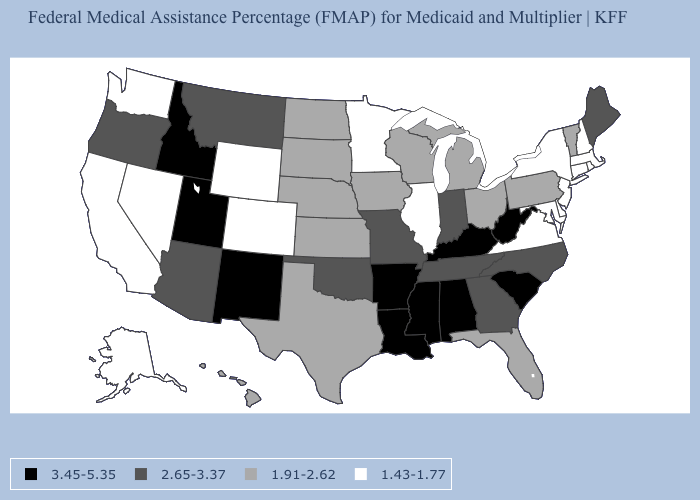Name the states that have a value in the range 2.65-3.37?
Answer briefly. Arizona, Georgia, Indiana, Maine, Missouri, Montana, North Carolina, Oklahoma, Oregon, Tennessee. What is the value of New Jersey?
Answer briefly. 1.43-1.77. What is the value of North Carolina?
Write a very short answer. 2.65-3.37. Which states have the lowest value in the West?
Keep it brief. Alaska, California, Colorado, Nevada, Washington, Wyoming. What is the lowest value in the South?
Short answer required. 1.43-1.77. Which states have the lowest value in the USA?
Give a very brief answer. Alaska, California, Colorado, Connecticut, Delaware, Illinois, Maryland, Massachusetts, Minnesota, Nevada, New Hampshire, New Jersey, New York, Rhode Island, Virginia, Washington, Wyoming. What is the lowest value in states that border New York?
Answer briefly. 1.43-1.77. Does Pennsylvania have the highest value in the Northeast?
Be succinct. No. Does Indiana have the highest value in the MidWest?
Give a very brief answer. Yes. Among the states that border North Carolina , which have the lowest value?
Write a very short answer. Virginia. What is the lowest value in the Northeast?
Concise answer only. 1.43-1.77. Name the states that have a value in the range 2.65-3.37?
Be succinct. Arizona, Georgia, Indiana, Maine, Missouri, Montana, North Carolina, Oklahoma, Oregon, Tennessee. Name the states that have a value in the range 1.43-1.77?
Short answer required. Alaska, California, Colorado, Connecticut, Delaware, Illinois, Maryland, Massachusetts, Minnesota, Nevada, New Hampshire, New Jersey, New York, Rhode Island, Virginia, Washington, Wyoming. How many symbols are there in the legend?
Keep it brief. 4. 